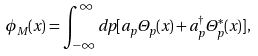Convert formula to latex. <formula><loc_0><loc_0><loc_500><loc_500>\phi _ { M } ( x ) = \int _ { - \infty } ^ { \infty } d p [ a _ { p } \Theta _ { p } ( x ) + a _ { p } ^ { \dag } \Theta _ { p } ^ { * } ( x ) ] ,</formula> 